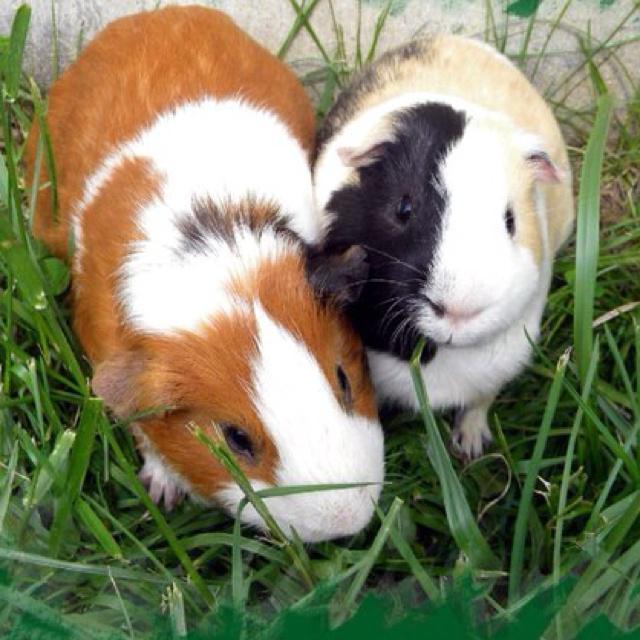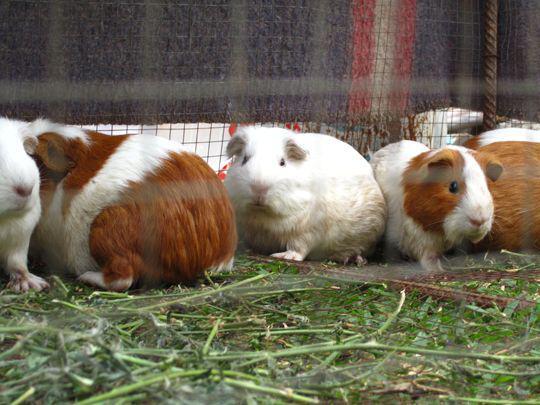The first image is the image on the left, the second image is the image on the right. Given the left and right images, does the statement "At least one of the images is of a single guinea pig laying in the grass." hold true? Answer yes or no. No. 